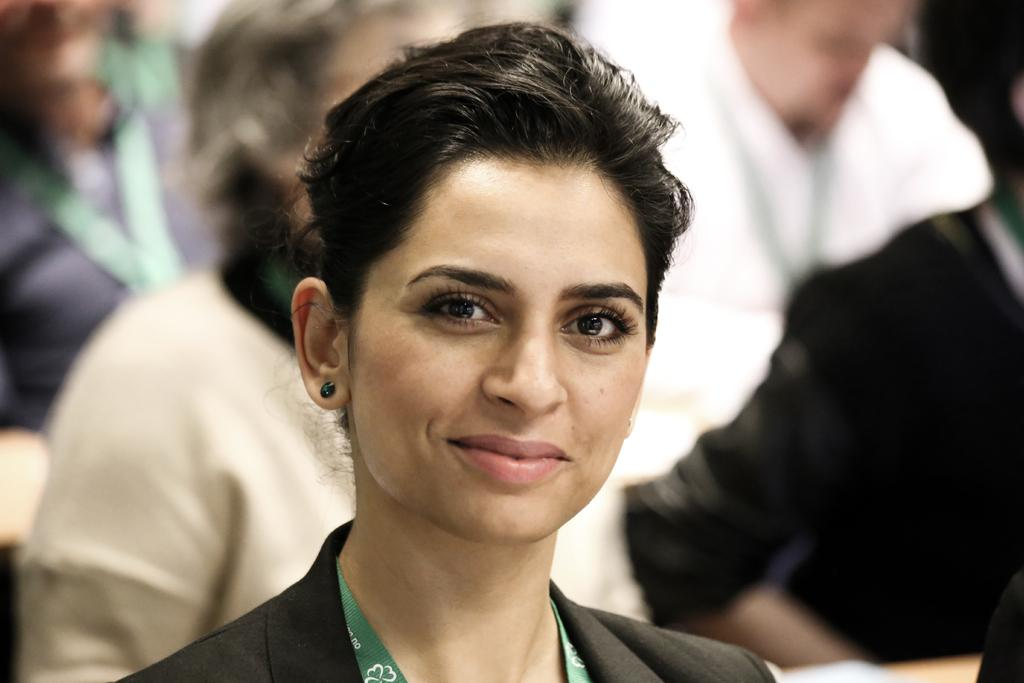Who is the main subject in the image? There is a woman in the image. What is the woman doing in the image? The woman is smiling. Can you describe the people in the background of the image? There are other persons in the background of the image, and they are wearing different color dresses. What type of veil can be seen on the train in the image? There is no train or veil present in the image. What thrilling activity are the persons in the background participating in? There is no indication of any thrilling activity in the image; the persons in the background are simply wearing different color dresses. 